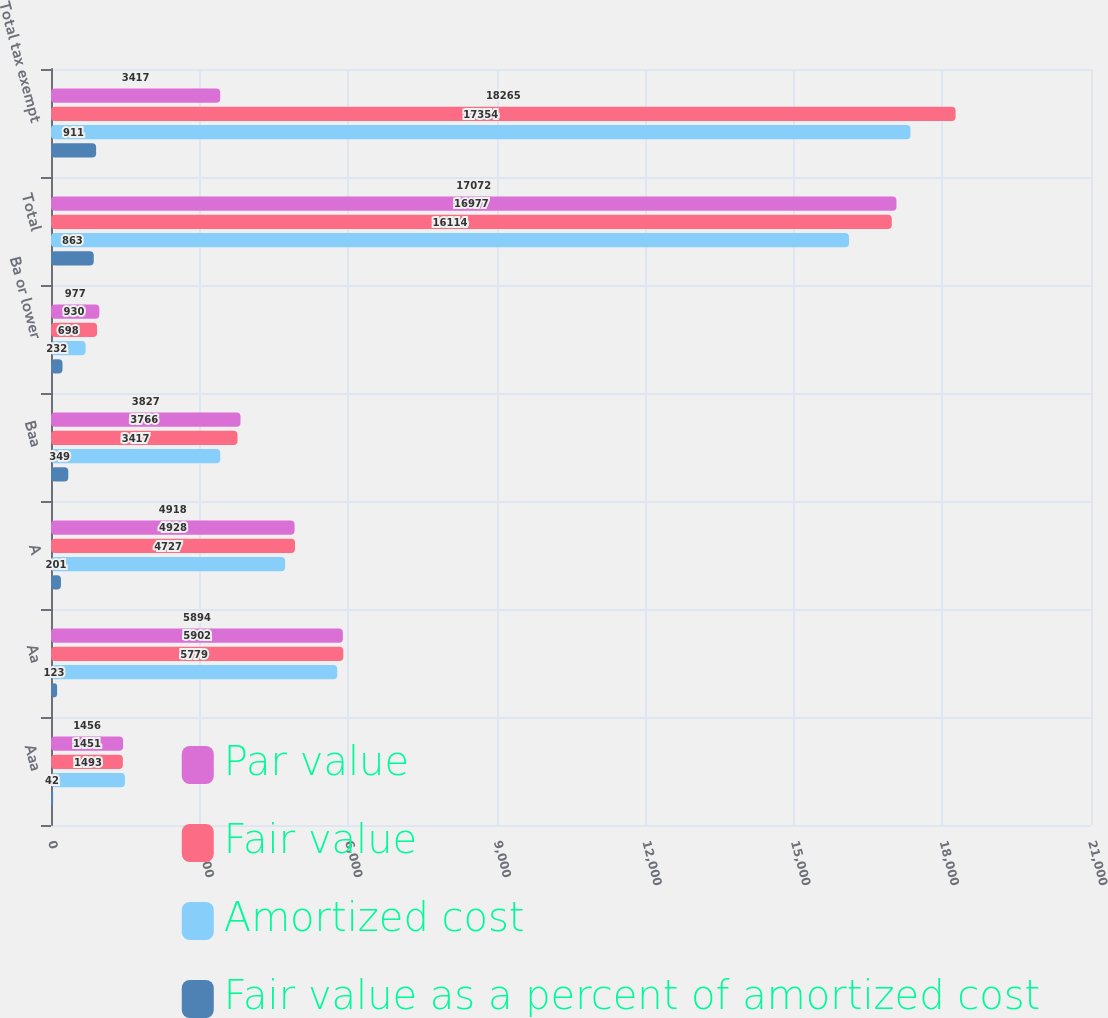Convert chart to OTSL. <chart><loc_0><loc_0><loc_500><loc_500><stacked_bar_chart><ecel><fcel>Aaa<fcel>Aa<fcel>A<fcel>Baa<fcel>Ba or lower<fcel>Total<fcel>Total tax exempt<nl><fcel>Par value<fcel>1456<fcel>5894<fcel>4918<fcel>3827<fcel>977<fcel>17072<fcel>3417<nl><fcel>Fair value<fcel>1451<fcel>5902<fcel>4928<fcel>3766<fcel>930<fcel>16977<fcel>18265<nl><fcel>Amortized cost<fcel>1493<fcel>5779<fcel>4727<fcel>3417<fcel>698<fcel>16114<fcel>17354<nl><fcel>Fair value as a percent of amortized cost<fcel>42<fcel>123<fcel>201<fcel>349<fcel>232<fcel>863<fcel>911<nl></chart> 